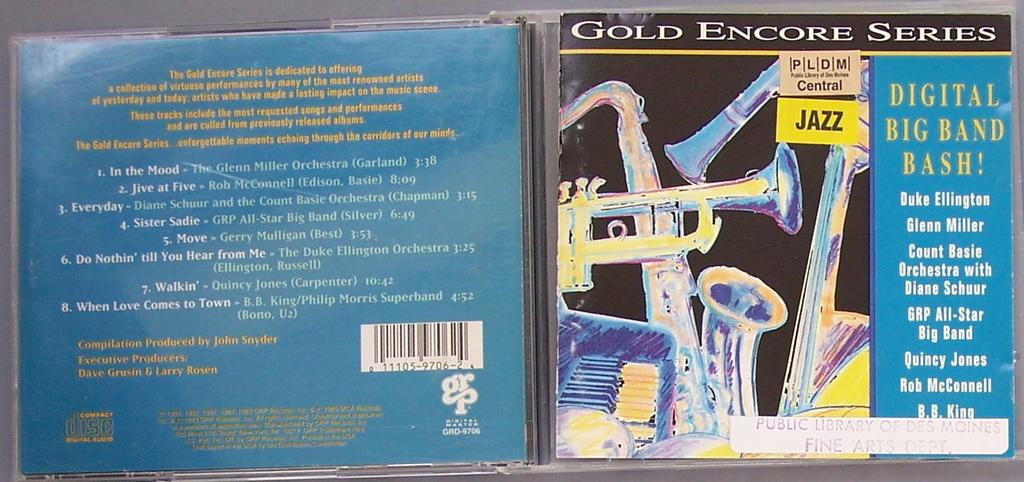Provide a one-sentence caption for the provided image. a GOLD ENCORE SERIES Jazz music CD which has DIGITAL BIG BAND BASH! on it with the likes of Duke Ellington, Glen Miller, Count Basie, B.B. King, etc. 